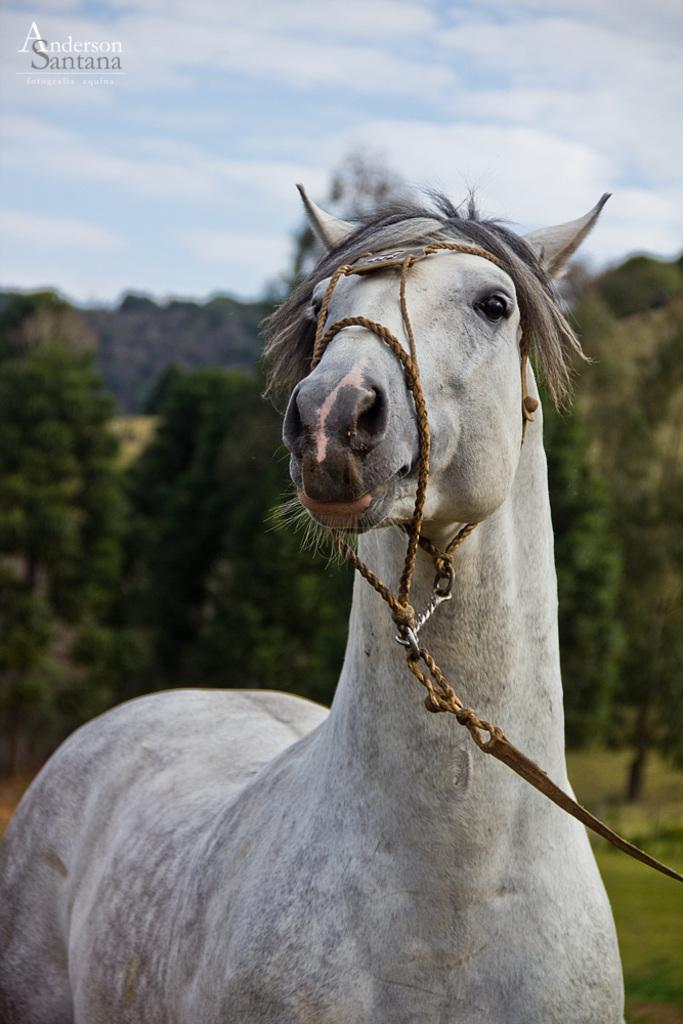What animal is the main subject of the image? There is a horse in the image. Does the horse have any accessories or equipment? Yes, the horse has a belt. What can be seen in the background of the image? There are trees, the ground, and the sky visible in the background of the image. What is the condition of the sky in the image? The sky has clouds in it. Is there any text present in the image? Yes, there is text present in the image. What type of glass is being used to play basketball in the image? There is no glass or basketball present in the image; it features a horse with a belt and a background with trees, the ground, and the sky. 